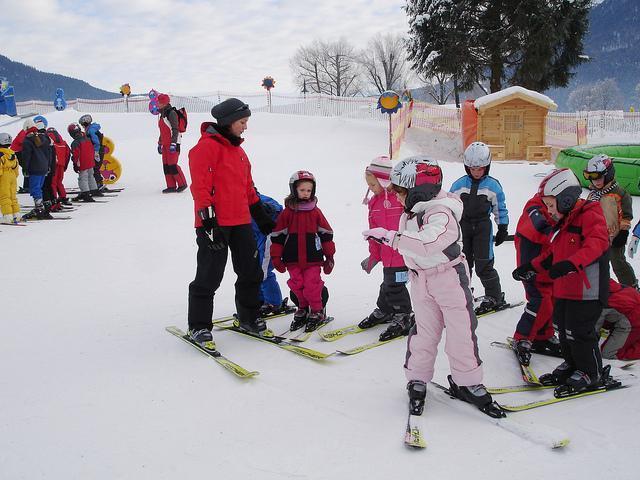How many people are in the photo?
Give a very brief answer. 10. How many donuts are chocolate?
Give a very brief answer. 0. 